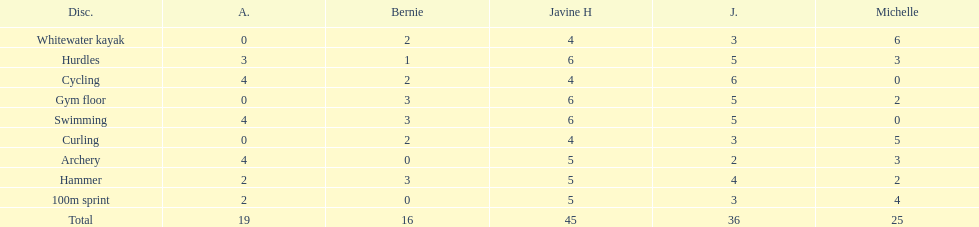Who had the least points in the whitewater kayak event? Amanda. 